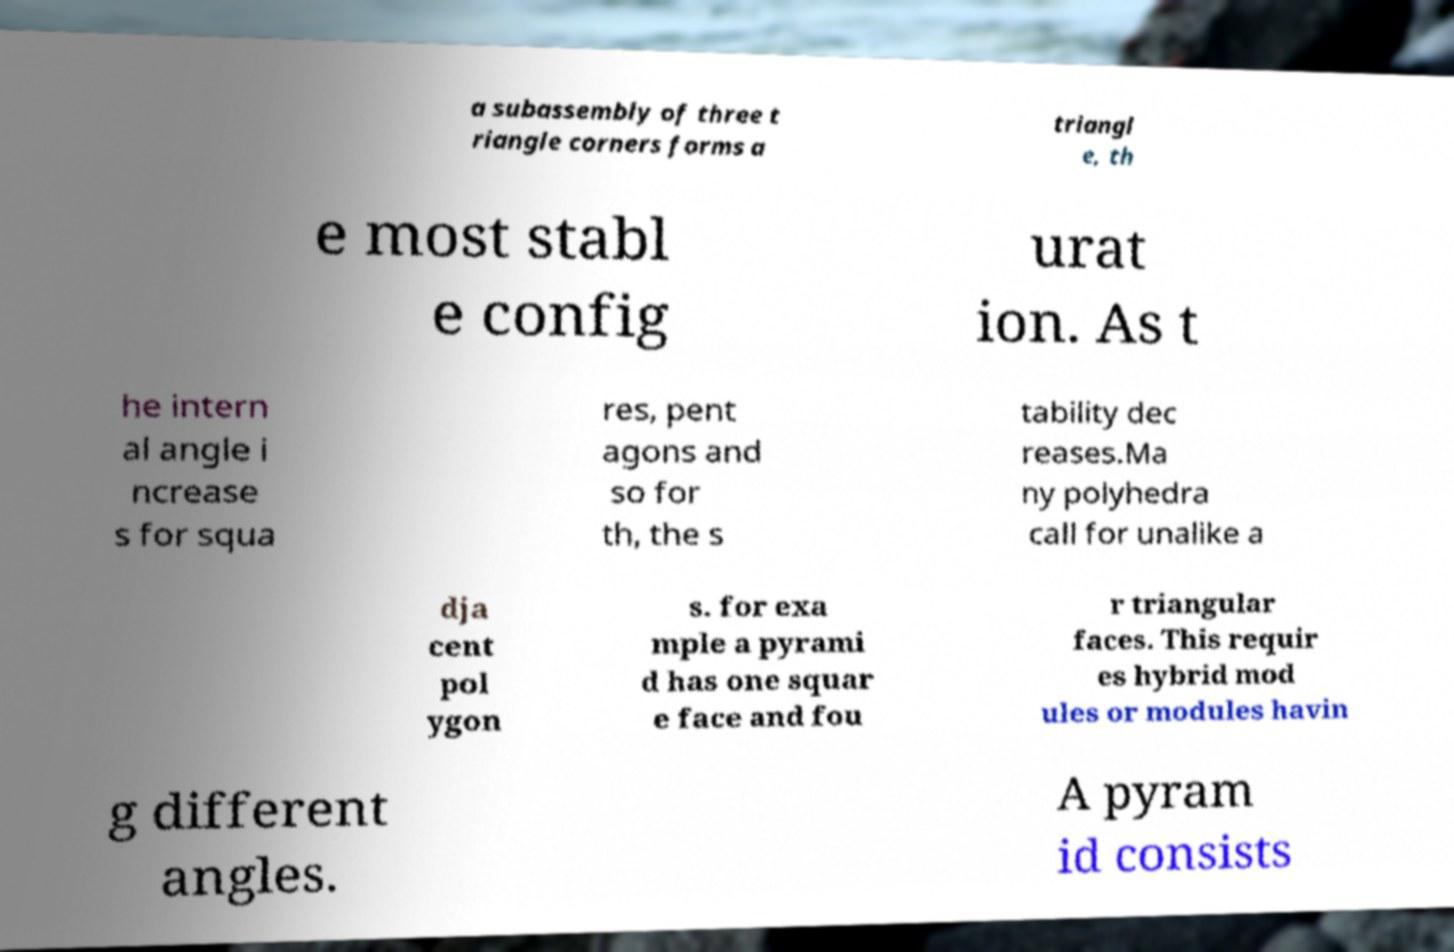Please identify and transcribe the text found in this image. a subassembly of three t riangle corners forms a triangl e, th e most stabl e config urat ion. As t he intern al angle i ncrease s for squa res, pent agons and so for th, the s tability dec reases.Ma ny polyhedra call for unalike a dja cent pol ygon s. for exa mple a pyrami d has one squar e face and fou r triangular faces. This requir es hybrid mod ules or modules havin g different angles. A pyram id consists 